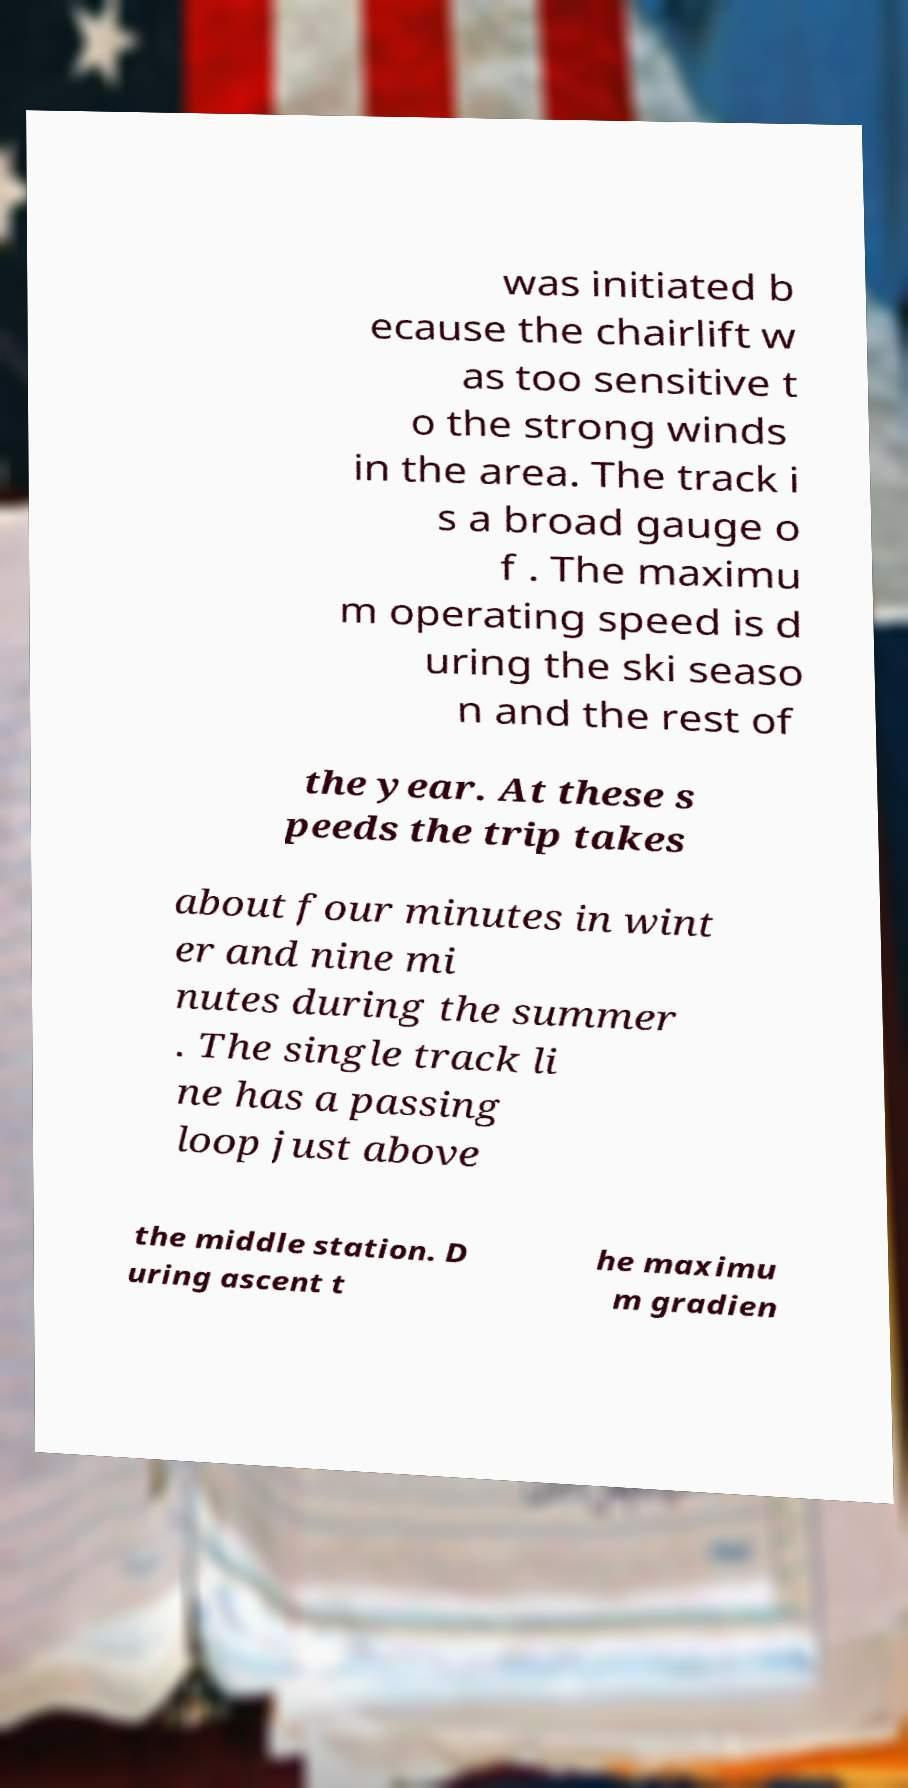Please identify and transcribe the text found in this image. was initiated b ecause the chairlift w as too sensitive t o the strong winds in the area. The track i s a broad gauge o f . The maximu m operating speed is d uring the ski seaso n and the rest of the year. At these s peeds the trip takes about four minutes in wint er and nine mi nutes during the summer . The single track li ne has a passing loop just above the middle station. D uring ascent t he maximu m gradien 